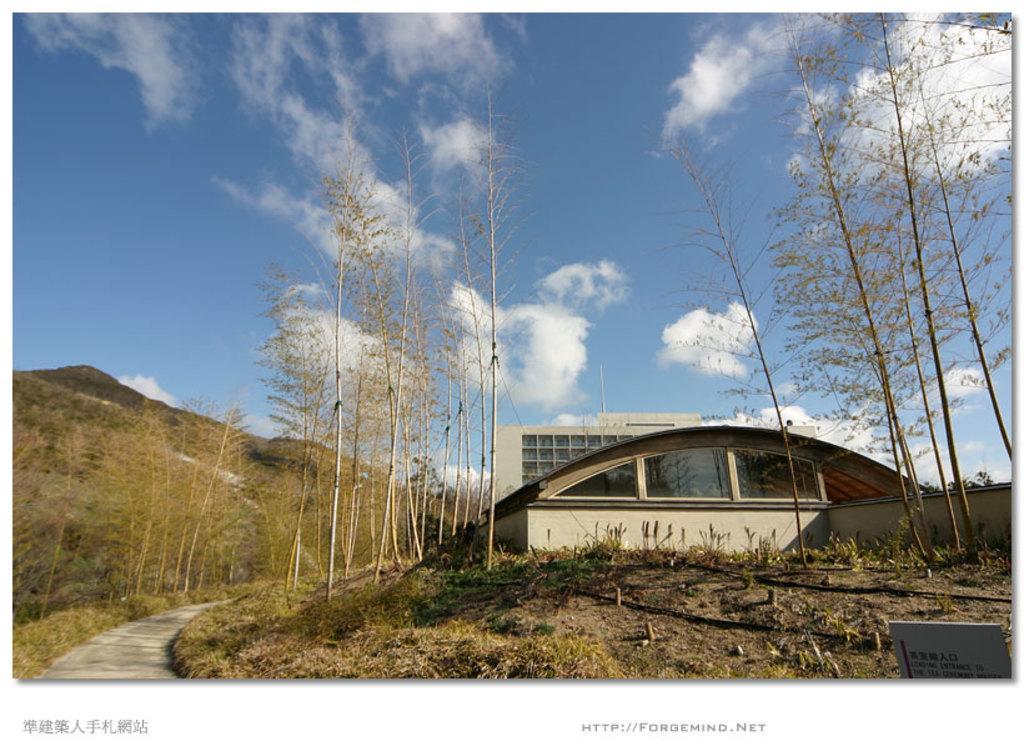Can you describe this image briefly? In this image I can see few trees in green color. In the background I can see the building, few glass windows, mountains and the sky is in blue and white color. 